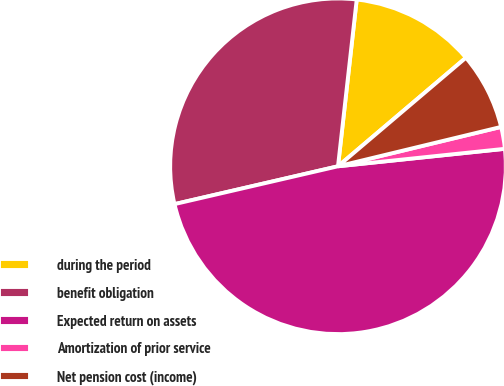Convert chart. <chart><loc_0><loc_0><loc_500><loc_500><pie_chart><fcel>during the period<fcel>benefit obligation<fcel>Expected return on assets<fcel>Amortization of prior service<fcel>Net pension cost (income)<nl><fcel>12.02%<fcel>30.4%<fcel>48.04%<fcel>2.11%<fcel>7.43%<nl></chart> 